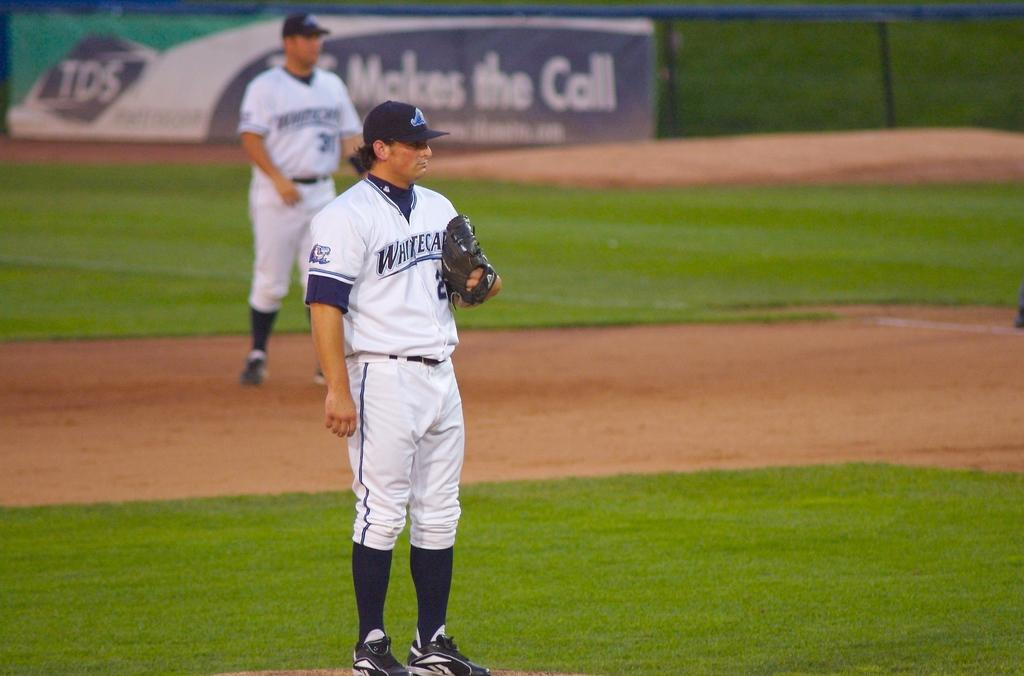<image>
Render a clear and concise summary of the photo. Two baseball players for the West Michigan White Caps are standing around on the field. 